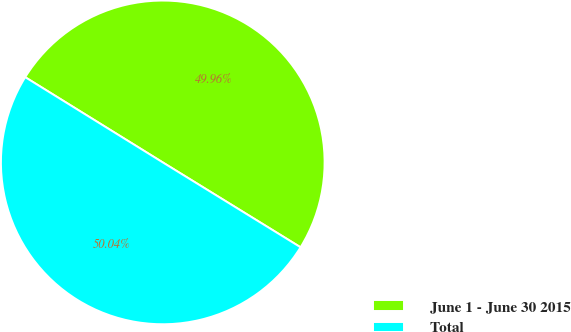<chart> <loc_0><loc_0><loc_500><loc_500><pie_chart><fcel>June 1 - June 30 2015<fcel>Total<nl><fcel>49.96%<fcel>50.04%<nl></chart> 